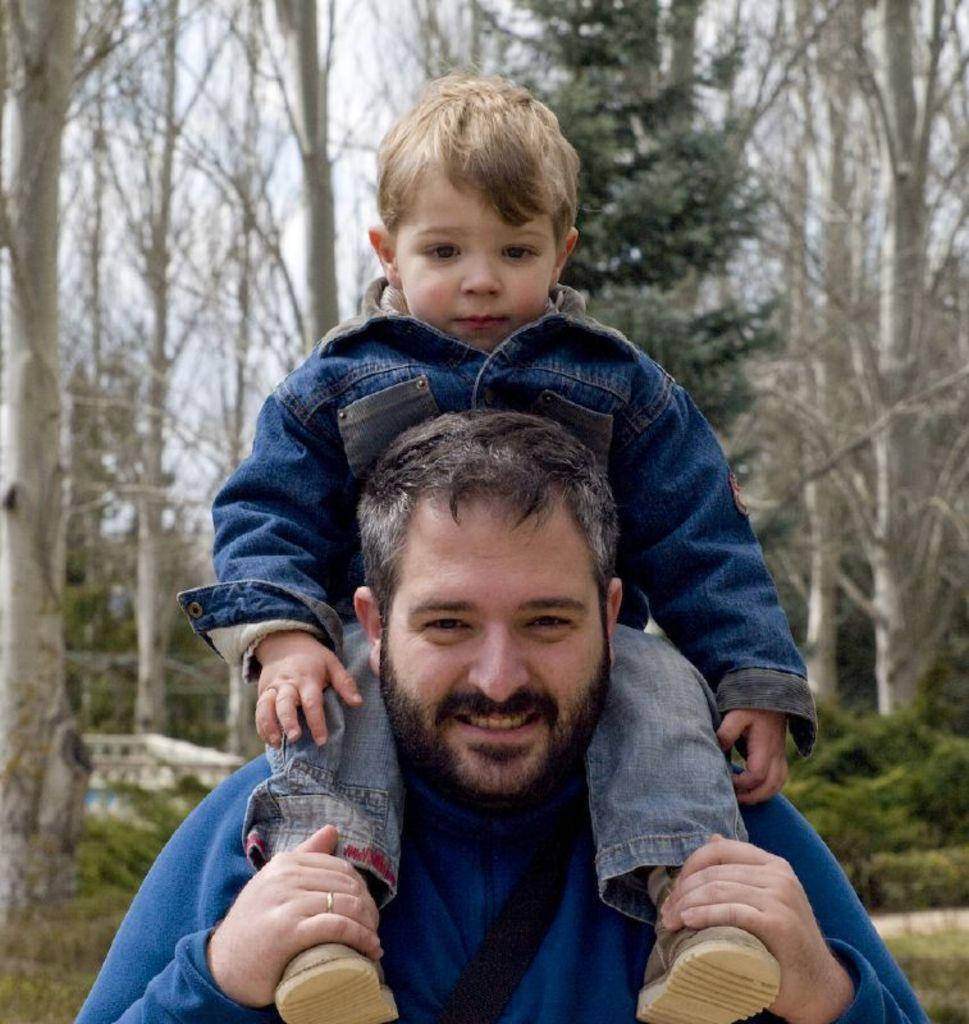Who is the main subject in the center of the image? There is a man in the center of the image. What is the man doing in the image? The man has a small boy on his shoulders. What can be seen in the background of the image? There are trees in the background of the image. What type of eggnog is being served at the church in the image? There is no church or eggnog present in the image; it features a man with a small boy on his shoulders and trees in the background. 